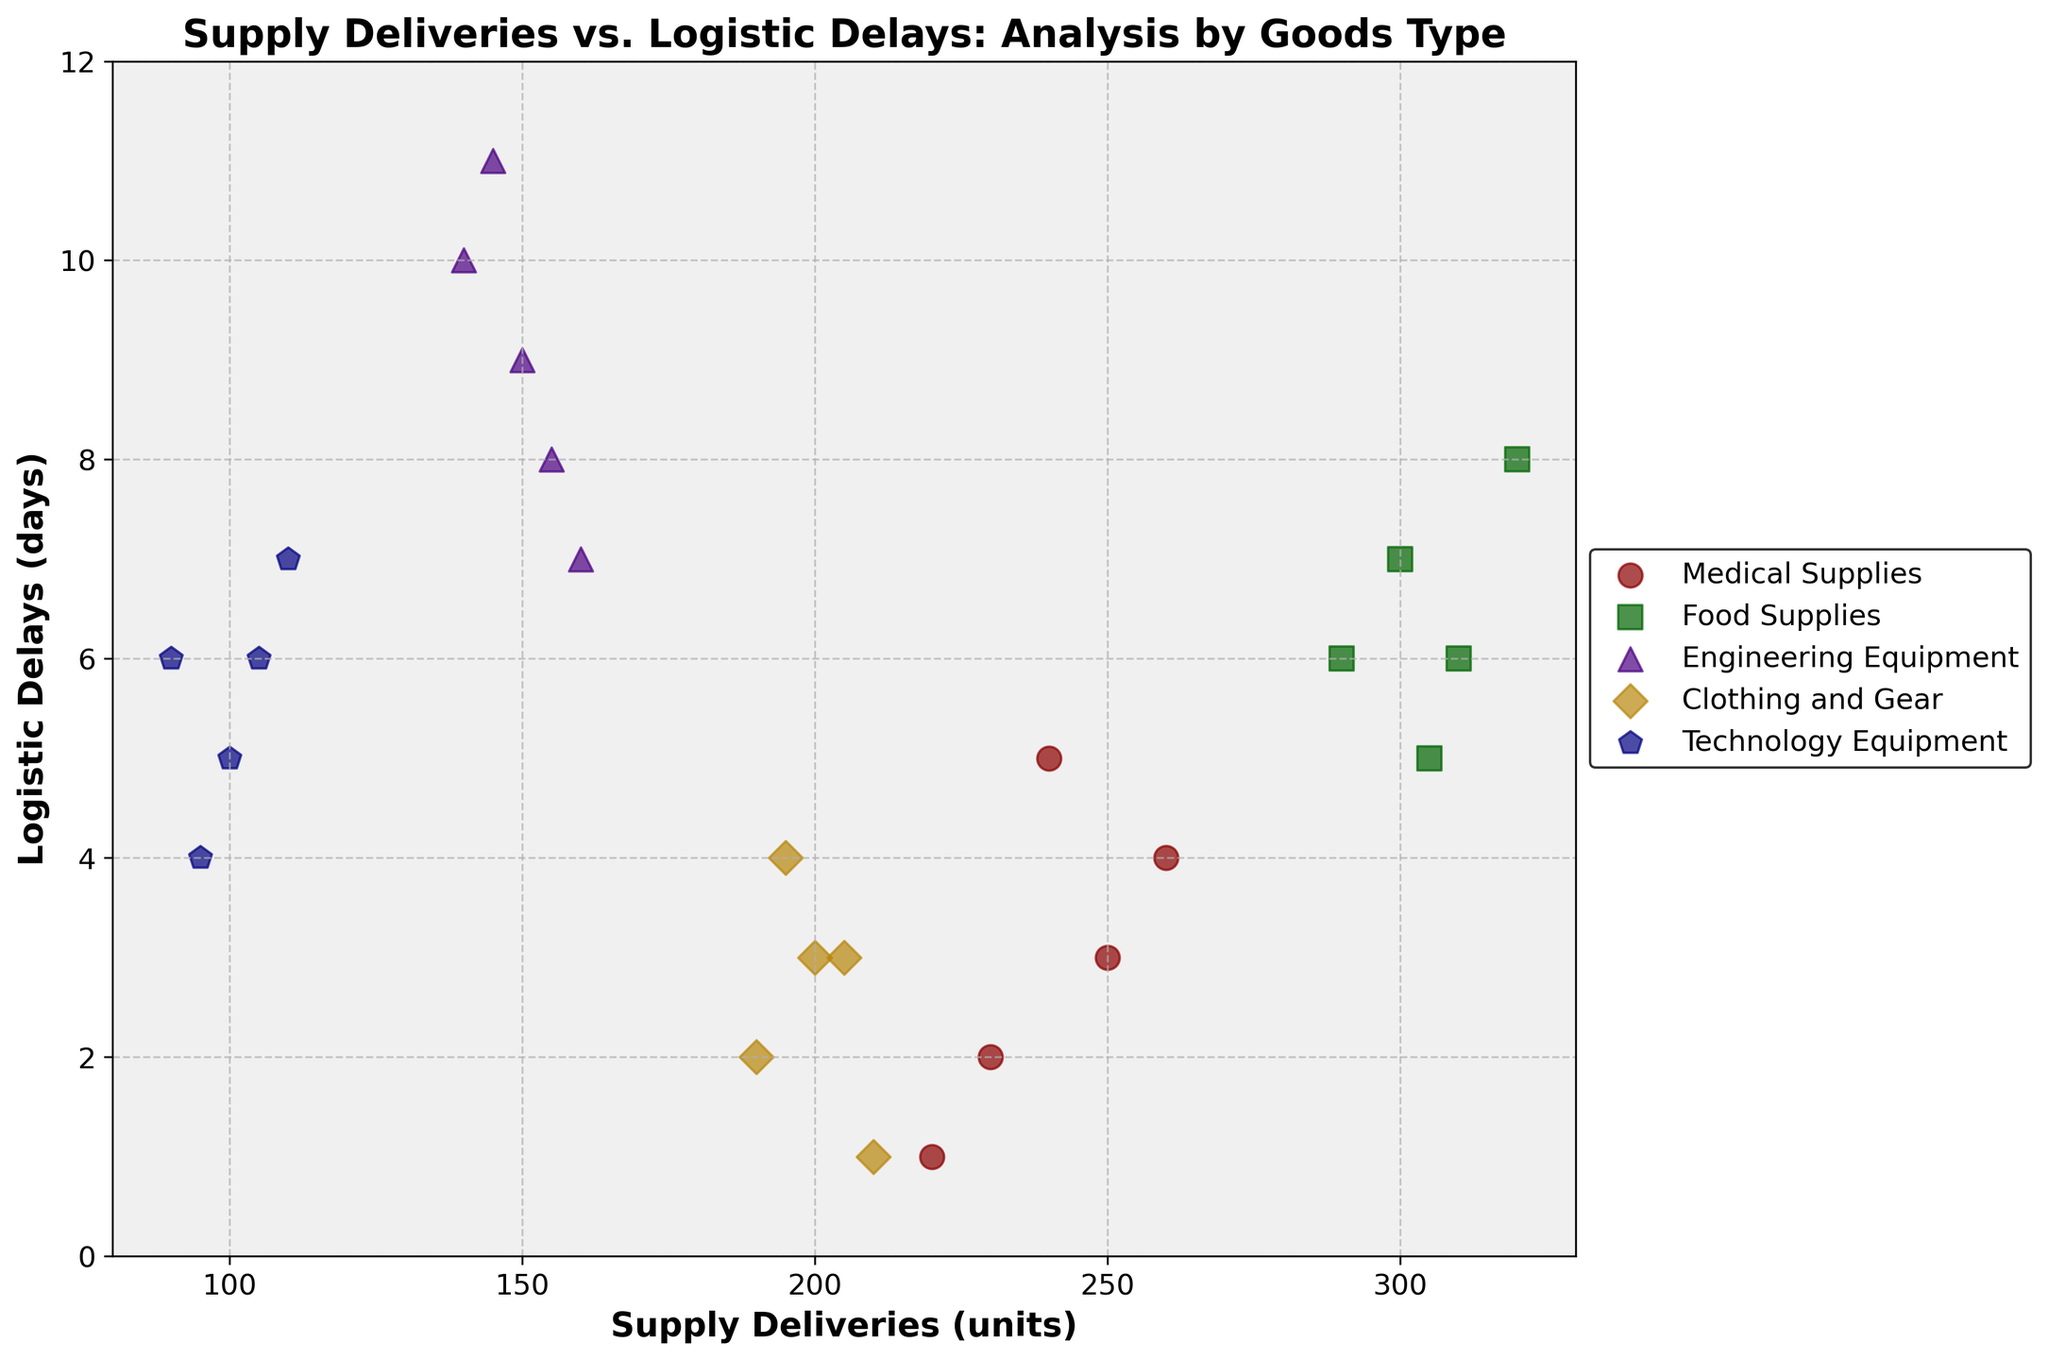What are the axes' labels? The x-axis is labeled 'Supply Deliveries (units)' and the y-axis is labeled 'Logistic Delays (days)'.
Answer: Supply Deliveries (units); Logistic Delays (days) How many goods types are represented in the plot? There are five goods types represented, one for each color and marker used in the plot.
Answer: 5 Which goods type has the highest supply delivery and what is the value? The highest delivery is by 'Food Supplies' which has a value of 320 units.
Answer: Food Supplies, 320 units Which goods type experiences the least logistic delays overall? 'Clothing and Gear' has data points with the lowest logistic delays, ranging from 1 to 4 days.
Answer: Clothing and Gear What's the maximum logistic delay observed in the plot? The maximum logistic delay observed is 11 days for 'Engineering Equipment'.
Answer: 11 days What is the average logistic delay for 'Medical Supplies'? The logistic delays for 'Medical Supplies' are 3, 2, 5, 4, and 1. The average is (3+2+5+4+1)/5 = 3 days.
Answer: 3 days Which goods type has the most variability in supply deliveries? 'Food Supplies' show the most variability as their deliveries range from 290 to 320 units.
Answer: Food Supplies How do the logistic delays for 'Technology Equipment' compare to those for 'Medical Supplies'? 'Technology Equipment' has logistic delays ranging from 4 to 7 days, while 'Medical Supplies' ranges from 1 to 5 days, indicating that 'Technology Equipment' generally has longer delays.
Answer: Technology Equipment has longer delays Are there any goods types that consistently show a positive relationship between supply deliveries and logistic delays? 'Food Supplies' consistently show a positive relationship between higher supply deliveries and longer logistic delays.
Answer: Yes, Food Supplies Which goods type is the most clustered in terms of data points? 'Clothing and Gear' is the most clustered with supply deliveries between 190 and 210 units and logistic delays between 1 and 4 days.
Answer: Clothing and Gear 